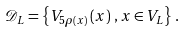<formula> <loc_0><loc_0><loc_500><loc_500>\mathcal { D } _ { L } = \left \{ V _ { 5 \rho \left ( x \right ) } \left ( x \right ) \, , x \in V _ { L } \right \} \, .</formula> 